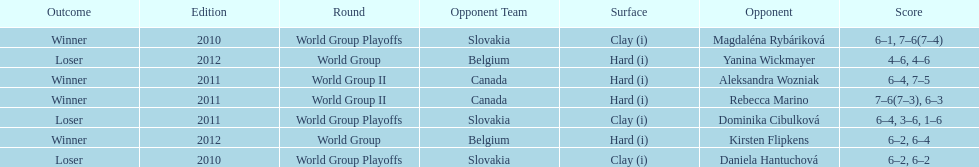What is the other year slovakia played besides 2010? 2011. 